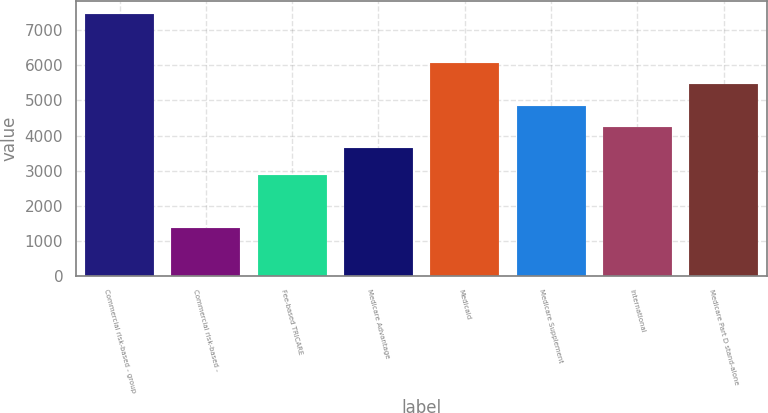Convert chart to OTSL. <chart><loc_0><loc_0><loc_500><loc_500><bar_chart><fcel>Commercial risk-based - group<fcel>Commercial risk-based -<fcel>Fee-based TRICARE<fcel>Medicare Advantage<fcel>Medicaid<fcel>Medicare Supplement<fcel>International<fcel>Medicare Part D stand-alone<nl><fcel>7470<fcel>1350<fcel>2860<fcel>3630<fcel>6078<fcel>4854<fcel>4242<fcel>5466<nl></chart> 